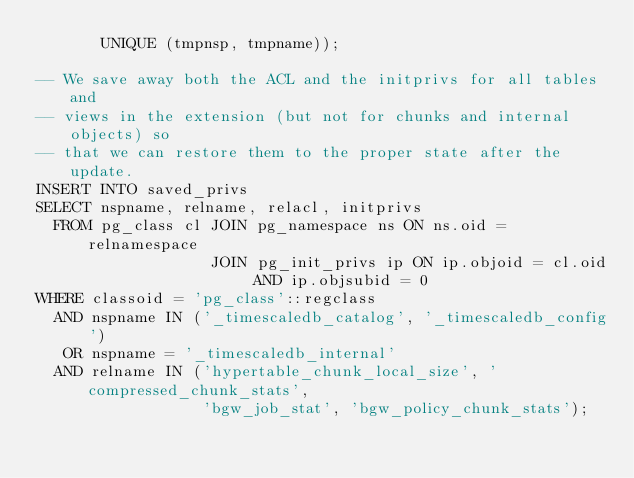Convert code to text. <code><loc_0><loc_0><loc_500><loc_500><_SQL_>       UNIQUE (tmpnsp, tmpname));

-- We save away both the ACL and the initprivs for all tables and
-- views in the extension (but not for chunks and internal objects) so
-- that we can restore them to the proper state after the update.
INSERT INTO saved_privs
SELECT nspname, relname, relacl, initprivs
  FROM pg_class cl JOIN pg_namespace ns ON ns.oid = relnamespace
                   JOIN pg_init_privs ip ON ip.objoid = cl.oid AND ip.objsubid = 0
WHERE classoid = 'pg_class'::regclass
  AND nspname IN ('_timescaledb_catalog', '_timescaledb_config')
   OR nspname = '_timescaledb_internal'
  AND relname IN ('hypertable_chunk_local_size', 'compressed_chunk_stats',
                  'bgw_job_stat', 'bgw_policy_chunk_stats');

</code> 